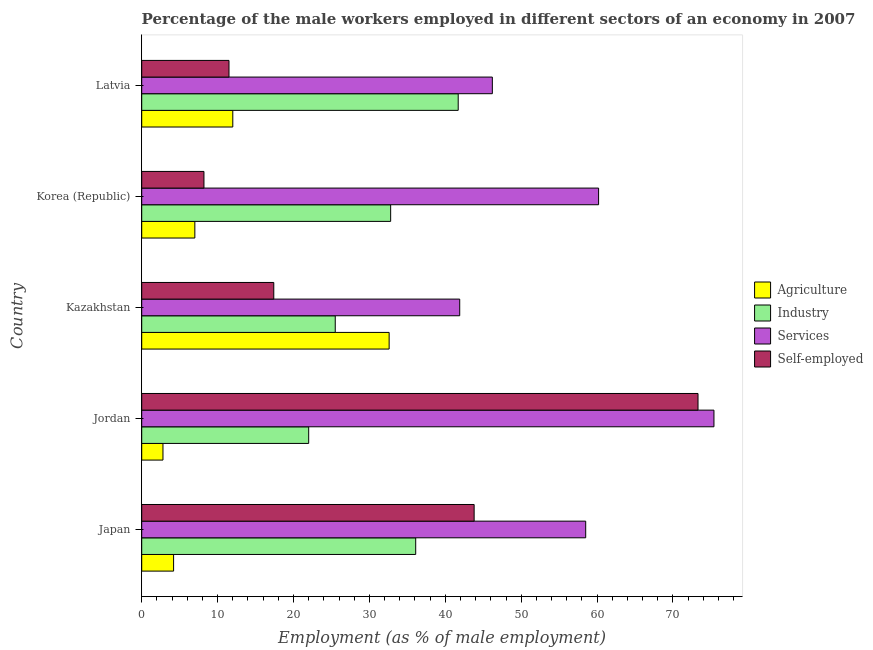How many groups of bars are there?
Offer a very short reply. 5. Are the number of bars on each tick of the Y-axis equal?
Your answer should be very brief. Yes. How many bars are there on the 3rd tick from the top?
Your answer should be compact. 4. What is the label of the 4th group of bars from the top?
Provide a succinct answer. Jordan. In how many cases, is the number of bars for a given country not equal to the number of legend labels?
Your answer should be compact. 0. Across all countries, what is the maximum percentage of male workers in agriculture?
Your answer should be very brief. 32.6. Across all countries, what is the minimum percentage of self employed male workers?
Offer a very short reply. 8.2. In which country was the percentage of male workers in agriculture maximum?
Provide a succinct answer. Kazakhstan. In which country was the percentage of male workers in industry minimum?
Keep it short and to the point. Jordan. What is the total percentage of self employed male workers in the graph?
Keep it short and to the point. 154.2. What is the difference between the percentage of self employed male workers in Japan and that in Korea (Republic)?
Your answer should be compact. 35.6. What is the difference between the percentage of male workers in services in Korea (Republic) and the percentage of male workers in industry in Kazakhstan?
Give a very brief answer. 34.7. What is the average percentage of self employed male workers per country?
Your response must be concise. 30.84. What is the difference between the percentage of male workers in services and percentage of male workers in industry in Latvia?
Your answer should be very brief. 4.5. In how many countries, is the percentage of self employed male workers greater than 10 %?
Ensure brevity in your answer.  4. What is the ratio of the percentage of male workers in industry in Japan to that in Latvia?
Keep it short and to the point. 0.87. Is the percentage of self employed male workers in Japan less than that in Latvia?
Provide a short and direct response. No. In how many countries, is the percentage of male workers in services greater than the average percentage of male workers in services taken over all countries?
Make the answer very short. 3. Is the sum of the percentage of male workers in industry in Japan and Latvia greater than the maximum percentage of male workers in services across all countries?
Keep it short and to the point. Yes. What does the 4th bar from the top in Kazakhstan represents?
Offer a terse response. Agriculture. What does the 4th bar from the bottom in Kazakhstan represents?
Offer a terse response. Self-employed. How many bars are there?
Offer a terse response. 20. Are all the bars in the graph horizontal?
Keep it short and to the point. Yes. How many countries are there in the graph?
Offer a very short reply. 5. What is the difference between two consecutive major ticks on the X-axis?
Your response must be concise. 10. Are the values on the major ticks of X-axis written in scientific E-notation?
Give a very brief answer. No. Does the graph contain grids?
Ensure brevity in your answer.  No. How many legend labels are there?
Give a very brief answer. 4. What is the title of the graph?
Offer a very short reply. Percentage of the male workers employed in different sectors of an economy in 2007. What is the label or title of the X-axis?
Your response must be concise. Employment (as % of male employment). What is the label or title of the Y-axis?
Keep it short and to the point. Country. What is the Employment (as % of male employment) in Agriculture in Japan?
Give a very brief answer. 4.2. What is the Employment (as % of male employment) of Industry in Japan?
Offer a terse response. 36.1. What is the Employment (as % of male employment) of Services in Japan?
Your response must be concise. 58.5. What is the Employment (as % of male employment) of Self-employed in Japan?
Ensure brevity in your answer.  43.8. What is the Employment (as % of male employment) in Agriculture in Jordan?
Your answer should be very brief. 2.8. What is the Employment (as % of male employment) in Services in Jordan?
Offer a terse response. 75.4. What is the Employment (as % of male employment) in Self-employed in Jordan?
Your answer should be very brief. 73.3. What is the Employment (as % of male employment) of Agriculture in Kazakhstan?
Give a very brief answer. 32.6. What is the Employment (as % of male employment) in Industry in Kazakhstan?
Your answer should be very brief. 25.5. What is the Employment (as % of male employment) in Services in Kazakhstan?
Offer a very short reply. 41.9. What is the Employment (as % of male employment) of Self-employed in Kazakhstan?
Your response must be concise. 17.4. What is the Employment (as % of male employment) in Agriculture in Korea (Republic)?
Your response must be concise. 7. What is the Employment (as % of male employment) of Industry in Korea (Republic)?
Make the answer very short. 32.8. What is the Employment (as % of male employment) in Services in Korea (Republic)?
Provide a succinct answer. 60.2. What is the Employment (as % of male employment) in Self-employed in Korea (Republic)?
Provide a short and direct response. 8.2. What is the Employment (as % of male employment) of Industry in Latvia?
Make the answer very short. 41.7. What is the Employment (as % of male employment) in Services in Latvia?
Provide a short and direct response. 46.2. Across all countries, what is the maximum Employment (as % of male employment) of Agriculture?
Keep it short and to the point. 32.6. Across all countries, what is the maximum Employment (as % of male employment) of Industry?
Ensure brevity in your answer.  41.7. Across all countries, what is the maximum Employment (as % of male employment) in Services?
Keep it short and to the point. 75.4. Across all countries, what is the maximum Employment (as % of male employment) in Self-employed?
Your answer should be very brief. 73.3. Across all countries, what is the minimum Employment (as % of male employment) in Agriculture?
Your response must be concise. 2.8. Across all countries, what is the minimum Employment (as % of male employment) in Services?
Offer a terse response. 41.9. Across all countries, what is the minimum Employment (as % of male employment) in Self-employed?
Your answer should be compact. 8.2. What is the total Employment (as % of male employment) of Agriculture in the graph?
Offer a very short reply. 58.6. What is the total Employment (as % of male employment) in Industry in the graph?
Make the answer very short. 158.1. What is the total Employment (as % of male employment) in Services in the graph?
Offer a terse response. 282.2. What is the total Employment (as % of male employment) of Self-employed in the graph?
Ensure brevity in your answer.  154.2. What is the difference between the Employment (as % of male employment) in Industry in Japan and that in Jordan?
Make the answer very short. 14.1. What is the difference between the Employment (as % of male employment) in Services in Japan and that in Jordan?
Provide a short and direct response. -16.9. What is the difference between the Employment (as % of male employment) in Self-employed in Japan and that in Jordan?
Give a very brief answer. -29.5. What is the difference between the Employment (as % of male employment) of Agriculture in Japan and that in Kazakhstan?
Ensure brevity in your answer.  -28.4. What is the difference between the Employment (as % of male employment) in Services in Japan and that in Kazakhstan?
Provide a short and direct response. 16.6. What is the difference between the Employment (as % of male employment) of Self-employed in Japan and that in Kazakhstan?
Ensure brevity in your answer.  26.4. What is the difference between the Employment (as % of male employment) in Industry in Japan and that in Korea (Republic)?
Give a very brief answer. 3.3. What is the difference between the Employment (as % of male employment) in Self-employed in Japan and that in Korea (Republic)?
Keep it short and to the point. 35.6. What is the difference between the Employment (as % of male employment) in Industry in Japan and that in Latvia?
Make the answer very short. -5.6. What is the difference between the Employment (as % of male employment) in Services in Japan and that in Latvia?
Give a very brief answer. 12.3. What is the difference between the Employment (as % of male employment) of Self-employed in Japan and that in Latvia?
Offer a very short reply. 32.3. What is the difference between the Employment (as % of male employment) of Agriculture in Jordan and that in Kazakhstan?
Provide a short and direct response. -29.8. What is the difference between the Employment (as % of male employment) in Industry in Jordan and that in Kazakhstan?
Ensure brevity in your answer.  -3.5. What is the difference between the Employment (as % of male employment) of Services in Jordan and that in Kazakhstan?
Ensure brevity in your answer.  33.5. What is the difference between the Employment (as % of male employment) in Self-employed in Jordan and that in Kazakhstan?
Keep it short and to the point. 55.9. What is the difference between the Employment (as % of male employment) in Self-employed in Jordan and that in Korea (Republic)?
Give a very brief answer. 65.1. What is the difference between the Employment (as % of male employment) of Industry in Jordan and that in Latvia?
Offer a very short reply. -19.7. What is the difference between the Employment (as % of male employment) of Services in Jordan and that in Latvia?
Make the answer very short. 29.2. What is the difference between the Employment (as % of male employment) in Self-employed in Jordan and that in Latvia?
Provide a succinct answer. 61.8. What is the difference between the Employment (as % of male employment) in Agriculture in Kazakhstan and that in Korea (Republic)?
Ensure brevity in your answer.  25.6. What is the difference between the Employment (as % of male employment) of Industry in Kazakhstan and that in Korea (Republic)?
Provide a short and direct response. -7.3. What is the difference between the Employment (as % of male employment) of Services in Kazakhstan and that in Korea (Republic)?
Make the answer very short. -18.3. What is the difference between the Employment (as % of male employment) in Agriculture in Kazakhstan and that in Latvia?
Keep it short and to the point. 20.6. What is the difference between the Employment (as % of male employment) of Industry in Kazakhstan and that in Latvia?
Provide a succinct answer. -16.2. What is the difference between the Employment (as % of male employment) of Services in Kazakhstan and that in Latvia?
Offer a terse response. -4.3. What is the difference between the Employment (as % of male employment) of Services in Korea (Republic) and that in Latvia?
Keep it short and to the point. 14. What is the difference between the Employment (as % of male employment) of Agriculture in Japan and the Employment (as % of male employment) of Industry in Jordan?
Provide a short and direct response. -17.8. What is the difference between the Employment (as % of male employment) in Agriculture in Japan and the Employment (as % of male employment) in Services in Jordan?
Offer a terse response. -71.2. What is the difference between the Employment (as % of male employment) of Agriculture in Japan and the Employment (as % of male employment) of Self-employed in Jordan?
Your answer should be compact. -69.1. What is the difference between the Employment (as % of male employment) in Industry in Japan and the Employment (as % of male employment) in Services in Jordan?
Make the answer very short. -39.3. What is the difference between the Employment (as % of male employment) of Industry in Japan and the Employment (as % of male employment) of Self-employed in Jordan?
Keep it short and to the point. -37.2. What is the difference between the Employment (as % of male employment) of Services in Japan and the Employment (as % of male employment) of Self-employed in Jordan?
Make the answer very short. -14.8. What is the difference between the Employment (as % of male employment) of Agriculture in Japan and the Employment (as % of male employment) of Industry in Kazakhstan?
Your response must be concise. -21.3. What is the difference between the Employment (as % of male employment) in Agriculture in Japan and the Employment (as % of male employment) in Services in Kazakhstan?
Provide a short and direct response. -37.7. What is the difference between the Employment (as % of male employment) of Agriculture in Japan and the Employment (as % of male employment) of Self-employed in Kazakhstan?
Ensure brevity in your answer.  -13.2. What is the difference between the Employment (as % of male employment) of Services in Japan and the Employment (as % of male employment) of Self-employed in Kazakhstan?
Offer a terse response. 41.1. What is the difference between the Employment (as % of male employment) of Agriculture in Japan and the Employment (as % of male employment) of Industry in Korea (Republic)?
Provide a succinct answer. -28.6. What is the difference between the Employment (as % of male employment) in Agriculture in Japan and the Employment (as % of male employment) in Services in Korea (Republic)?
Give a very brief answer. -56. What is the difference between the Employment (as % of male employment) in Agriculture in Japan and the Employment (as % of male employment) in Self-employed in Korea (Republic)?
Offer a terse response. -4. What is the difference between the Employment (as % of male employment) of Industry in Japan and the Employment (as % of male employment) of Services in Korea (Republic)?
Offer a terse response. -24.1. What is the difference between the Employment (as % of male employment) of Industry in Japan and the Employment (as % of male employment) of Self-employed in Korea (Republic)?
Offer a very short reply. 27.9. What is the difference between the Employment (as % of male employment) in Services in Japan and the Employment (as % of male employment) in Self-employed in Korea (Republic)?
Offer a very short reply. 50.3. What is the difference between the Employment (as % of male employment) in Agriculture in Japan and the Employment (as % of male employment) in Industry in Latvia?
Your response must be concise. -37.5. What is the difference between the Employment (as % of male employment) of Agriculture in Japan and the Employment (as % of male employment) of Services in Latvia?
Your response must be concise. -42. What is the difference between the Employment (as % of male employment) in Industry in Japan and the Employment (as % of male employment) in Services in Latvia?
Your answer should be very brief. -10.1. What is the difference between the Employment (as % of male employment) in Industry in Japan and the Employment (as % of male employment) in Self-employed in Latvia?
Your answer should be compact. 24.6. What is the difference between the Employment (as % of male employment) in Services in Japan and the Employment (as % of male employment) in Self-employed in Latvia?
Ensure brevity in your answer.  47. What is the difference between the Employment (as % of male employment) in Agriculture in Jordan and the Employment (as % of male employment) in Industry in Kazakhstan?
Offer a very short reply. -22.7. What is the difference between the Employment (as % of male employment) in Agriculture in Jordan and the Employment (as % of male employment) in Services in Kazakhstan?
Provide a short and direct response. -39.1. What is the difference between the Employment (as % of male employment) in Agriculture in Jordan and the Employment (as % of male employment) in Self-employed in Kazakhstan?
Provide a succinct answer. -14.6. What is the difference between the Employment (as % of male employment) in Industry in Jordan and the Employment (as % of male employment) in Services in Kazakhstan?
Provide a short and direct response. -19.9. What is the difference between the Employment (as % of male employment) of Industry in Jordan and the Employment (as % of male employment) of Self-employed in Kazakhstan?
Ensure brevity in your answer.  4.6. What is the difference between the Employment (as % of male employment) in Agriculture in Jordan and the Employment (as % of male employment) in Services in Korea (Republic)?
Make the answer very short. -57.4. What is the difference between the Employment (as % of male employment) in Agriculture in Jordan and the Employment (as % of male employment) in Self-employed in Korea (Republic)?
Your answer should be compact. -5.4. What is the difference between the Employment (as % of male employment) in Industry in Jordan and the Employment (as % of male employment) in Services in Korea (Republic)?
Give a very brief answer. -38.2. What is the difference between the Employment (as % of male employment) of Services in Jordan and the Employment (as % of male employment) of Self-employed in Korea (Republic)?
Your response must be concise. 67.2. What is the difference between the Employment (as % of male employment) in Agriculture in Jordan and the Employment (as % of male employment) in Industry in Latvia?
Offer a terse response. -38.9. What is the difference between the Employment (as % of male employment) of Agriculture in Jordan and the Employment (as % of male employment) of Services in Latvia?
Ensure brevity in your answer.  -43.4. What is the difference between the Employment (as % of male employment) of Industry in Jordan and the Employment (as % of male employment) of Services in Latvia?
Offer a terse response. -24.2. What is the difference between the Employment (as % of male employment) in Industry in Jordan and the Employment (as % of male employment) in Self-employed in Latvia?
Your answer should be compact. 10.5. What is the difference between the Employment (as % of male employment) of Services in Jordan and the Employment (as % of male employment) of Self-employed in Latvia?
Keep it short and to the point. 63.9. What is the difference between the Employment (as % of male employment) in Agriculture in Kazakhstan and the Employment (as % of male employment) in Services in Korea (Republic)?
Offer a very short reply. -27.6. What is the difference between the Employment (as % of male employment) of Agriculture in Kazakhstan and the Employment (as % of male employment) of Self-employed in Korea (Republic)?
Make the answer very short. 24.4. What is the difference between the Employment (as % of male employment) in Industry in Kazakhstan and the Employment (as % of male employment) in Services in Korea (Republic)?
Ensure brevity in your answer.  -34.7. What is the difference between the Employment (as % of male employment) in Industry in Kazakhstan and the Employment (as % of male employment) in Self-employed in Korea (Republic)?
Make the answer very short. 17.3. What is the difference between the Employment (as % of male employment) in Services in Kazakhstan and the Employment (as % of male employment) in Self-employed in Korea (Republic)?
Provide a short and direct response. 33.7. What is the difference between the Employment (as % of male employment) in Agriculture in Kazakhstan and the Employment (as % of male employment) in Industry in Latvia?
Your answer should be very brief. -9.1. What is the difference between the Employment (as % of male employment) of Agriculture in Kazakhstan and the Employment (as % of male employment) of Services in Latvia?
Your answer should be very brief. -13.6. What is the difference between the Employment (as % of male employment) of Agriculture in Kazakhstan and the Employment (as % of male employment) of Self-employed in Latvia?
Make the answer very short. 21.1. What is the difference between the Employment (as % of male employment) in Industry in Kazakhstan and the Employment (as % of male employment) in Services in Latvia?
Give a very brief answer. -20.7. What is the difference between the Employment (as % of male employment) in Services in Kazakhstan and the Employment (as % of male employment) in Self-employed in Latvia?
Your answer should be very brief. 30.4. What is the difference between the Employment (as % of male employment) in Agriculture in Korea (Republic) and the Employment (as % of male employment) in Industry in Latvia?
Give a very brief answer. -34.7. What is the difference between the Employment (as % of male employment) of Agriculture in Korea (Republic) and the Employment (as % of male employment) of Services in Latvia?
Ensure brevity in your answer.  -39.2. What is the difference between the Employment (as % of male employment) of Agriculture in Korea (Republic) and the Employment (as % of male employment) of Self-employed in Latvia?
Give a very brief answer. -4.5. What is the difference between the Employment (as % of male employment) in Industry in Korea (Republic) and the Employment (as % of male employment) in Services in Latvia?
Your answer should be very brief. -13.4. What is the difference between the Employment (as % of male employment) in Industry in Korea (Republic) and the Employment (as % of male employment) in Self-employed in Latvia?
Provide a succinct answer. 21.3. What is the difference between the Employment (as % of male employment) of Services in Korea (Republic) and the Employment (as % of male employment) of Self-employed in Latvia?
Your answer should be very brief. 48.7. What is the average Employment (as % of male employment) in Agriculture per country?
Keep it short and to the point. 11.72. What is the average Employment (as % of male employment) in Industry per country?
Your response must be concise. 31.62. What is the average Employment (as % of male employment) of Services per country?
Offer a very short reply. 56.44. What is the average Employment (as % of male employment) in Self-employed per country?
Your response must be concise. 30.84. What is the difference between the Employment (as % of male employment) of Agriculture and Employment (as % of male employment) of Industry in Japan?
Give a very brief answer. -31.9. What is the difference between the Employment (as % of male employment) of Agriculture and Employment (as % of male employment) of Services in Japan?
Give a very brief answer. -54.3. What is the difference between the Employment (as % of male employment) in Agriculture and Employment (as % of male employment) in Self-employed in Japan?
Your answer should be compact. -39.6. What is the difference between the Employment (as % of male employment) of Industry and Employment (as % of male employment) of Services in Japan?
Your response must be concise. -22.4. What is the difference between the Employment (as % of male employment) of Industry and Employment (as % of male employment) of Self-employed in Japan?
Ensure brevity in your answer.  -7.7. What is the difference between the Employment (as % of male employment) of Services and Employment (as % of male employment) of Self-employed in Japan?
Your answer should be very brief. 14.7. What is the difference between the Employment (as % of male employment) of Agriculture and Employment (as % of male employment) of Industry in Jordan?
Provide a succinct answer. -19.2. What is the difference between the Employment (as % of male employment) of Agriculture and Employment (as % of male employment) of Services in Jordan?
Your answer should be very brief. -72.6. What is the difference between the Employment (as % of male employment) of Agriculture and Employment (as % of male employment) of Self-employed in Jordan?
Offer a very short reply. -70.5. What is the difference between the Employment (as % of male employment) in Industry and Employment (as % of male employment) in Services in Jordan?
Your answer should be very brief. -53.4. What is the difference between the Employment (as % of male employment) in Industry and Employment (as % of male employment) in Self-employed in Jordan?
Your response must be concise. -51.3. What is the difference between the Employment (as % of male employment) in Services and Employment (as % of male employment) in Self-employed in Jordan?
Your answer should be compact. 2.1. What is the difference between the Employment (as % of male employment) in Agriculture and Employment (as % of male employment) in Services in Kazakhstan?
Make the answer very short. -9.3. What is the difference between the Employment (as % of male employment) in Agriculture and Employment (as % of male employment) in Self-employed in Kazakhstan?
Offer a very short reply. 15.2. What is the difference between the Employment (as % of male employment) of Industry and Employment (as % of male employment) of Services in Kazakhstan?
Provide a succinct answer. -16.4. What is the difference between the Employment (as % of male employment) in Agriculture and Employment (as % of male employment) in Industry in Korea (Republic)?
Give a very brief answer. -25.8. What is the difference between the Employment (as % of male employment) in Agriculture and Employment (as % of male employment) in Services in Korea (Republic)?
Ensure brevity in your answer.  -53.2. What is the difference between the Employment (as % of male employment) in Industry and Employment (as % of male employment) in Services in Korea (Republic)?
Your response must be concise. -27.4. What is the difference between the Employment (as % of male employment) of Industry and Employment (as % of male employment) of Self-employed in Korea (Republic)?
Offer a very short reply. 24.6. What is the difference between the Employment (as % of male employment) in Agriculture and Employment (as % of male employment) in Industry in Latvia?
Offer a terse response. -29.7. What is the difference between the Employment (as % of male employment) in Agriculture and Employment (as % of male employment) in Services in Latvia?
Offer a very short reply. -34.2. What is the difference between the Employment (as % of male employment) in Agriculture and Employment (as % of male employment) in Self-employed in Latvia?
Your answer should be very brief. 0.5. What is the difference between the Employment (as % of male employment) in Industry and Employment (as % of male employment) in Services in Latvia?
Offer a terse response. -4.5. What is the difference between the Employment (as % of male employment) of Industry and Employment (as % of male employment) of Self-employed in Latvia?
Give a very brief answer. 30.2. What is the difference between the Employment (as % of male employment) of Services and Employment (as % of male employment) of Self-employed in Latvia?
Your response must be concise. 34.7. What is the ratio of the Employment (as % of male employment) in Industry in Japan to that in Jordan?
Keep it short and to the point. 1.64. What is the ratio of the Employment (as % of male employment) of Services in Japan to that in Jordan?
Keep it short and to the point. 0.78. What is the ratio of the Employment (as % of male employment) in Self-employed in Japan to that in Jordan?
Keep it short and to the point. 0.6. What is the ratio of the Employment (as % of male employment) in Agriculture in Japan to that in Kazakhstan?
Your answer should be very brief. 0.13. What is the ratio of the Employment (as % of male employment) in Industry in Japan to that in Kazakhstan?
Your response must be concise. 1.42. What is the ratio of the Employment (as % of male employment) of Services in Japan to that in Kazakhstan?
Offer a very short reply. 1.4. What is the ratio of the Employment (as % of male employment) of Self-employed in Japan to that in Kazakhstan?
Offer a very short reply. 2.52. What is the ratio of the Employment (as % of male employment) in Agriculture in Japan to that in Korea (Republic)?
Provide a succinct answer. 0.6. What is the ratio of the Employment (as % of male employment) of Industry in Japan to that in Korea (Republic)?
Make the answer very short. 1.1. What is the ratio of the Employment (as % of male employment) in Services in Japan to that in Korea (Republic)?
Offer a very short reply. 0.97. What is the ratio of the Employment (as % of male employment) in Self-employed in Japan to that in Korea (Republic)?
Provide a succinct answer. 5.34. What is the ratio of the Employment (as % of male employment) in Industry in Japan to that in Latvia?
Make the answer very short. 0.87. What is the ratio of the Employment (as % of male employment) in Services in Japan to that in Latvia?
Provide a short and direct response. 1.27. What is the ratio of the Employment (as % of male employment) of Self-employed in Japan to that in Latvia?
Your answer should be compact. 3.81. What is the ratio of the Employment (as % of male employment) of Agriculture in Jordan to that in Kazakhstan?
Offer a terse response. 0.09. What is the ratio of the Employment (as % of male employment) in Industry in Jordan to that in Kazakhstan?
Keep it short and to the point. 0.86. What is the ratio of the Employment (as % of male employment) of Services in Jordan to that in Kazakhstan?
Keep it short and to the point. 1.8. What is the ratio of the Employment (as % of male employment) of Self-employed in Jordan to that in Kazakhstan?
Your answer should be very brief. 4.21. What is the ratio of the Employment (as % of male employment) in Agriculture in Jordan to that in Korea (Republic)?
Ensure brevity in your answer.  0.4. What is the ratio of the Employment (as % of male employment) of Industry in Jordan to that in Korea (Republic)?
Your answer should be compact. 0.67. What is the ratio of the Employment (as % of male employment) in Services in Jordan to that in Korea (Republic)?
Ensure brevity in your answer.  1.25. What is the ratio of the Employment (as % of male employment) of Self-employed in Jordan to that in Korea (Republic)?
Your answer should be compact. 8.94. What is the ratio of the Employment (as % of male employment) of Agriculture in Jordan to that in Latvia?
Provide a short and direct response. 0.23. What is the ratio of the Employment (as % of male employment) of Industry in Jordan to that in Latvia?
Make the answer very short. 0.53. What is the ratio of the Employment (as % of male employment) in Services in Jordan to that in Latvia?
Provide a succinct answer. 1.63. What is the ratio of the Employment (as % of male employment) of Self-employed in Jordan to that in Latvia?
Offer a terse response. 6.37. What is the ratio of the Employment (as % of male employment) of Agriculture in Kazakhstan to that in Korea (Republic)?
Provide a short and direct response. 4.66. What is the ratio of the Employment (as % of male employment) in Industry in Kazakhstan to that in Korea (Republic)?
Your answer should be very brief. 0.78. What is the ratio of the Employment (as % of male employment) in Services in Kazakhstan to that in Korea (Republic)?
Provide a succinct answer. 0.7. What is the ratio of the Employment (as % of male employment) of Self-employed in Kazakhstan to that in Korea (Republic)?
Your answer should be very brief. 2.12. What is the ratio of the Employment (as % of male employment) of Agriculture in Kazakhstan to that in Latvia?
Your answer should be very brief. 2.72. What is the ratio of the Employment (as % of male employment) in Industry in Kazakhstan to that in Latvia?
Make the answer very short. 0.61. What is the ratio of the Employment (as % of male employment) of Services in Kazakhstan to that in Latvia?
Provide a short and direct response. 0.91. What is the ratio of the Employment (as % of male employment) in Self-employed in Kazakhstan to that in Latvia?
Give a very brief answer. 1.51. What is the ratio of the Employment (as % of male employment) in Agriculture in Korea (Republic) to that in Latvia?
Your answer should be very brief. 0.58. What is the ratio of the Employment (as % of male employment) in Industry in Korea (Republic) to that in Latvia?
Provide a short and direct response. 0.79. What is the ratio of the Employment (as % of male employment) in Services in Korea (Republic) to that in Latvia?
Give a very brief answer. 1.3. What is the ratio of the Employment (as % of male employment) in Self-employed in Korea (Republic) to that in Latvia?
Provide a succinct answer. 0.71. What is the difference between the highest and the second highest Employment (as % of male employment) in Agriculture?
Offer a very short reply. 20.6. What is the difference between the highest and the second highest Employment (as % of male employment) of Services?
Offer a very short reply. 15.2. What is the difference between the highest and the second highest Employment (as % of male employment) in Self-employed?
Make the answer very short. 29.5. What is the difference between the highest and the lowest Employment (as % of male employment) of Agriculture?
Your answer should be very brief. 29.8. What is the difference between the highest and the lowest Employment (as % of male employment) of Services?
Keep it short and to the point. 33.5. What is the difference between the highest and the lowest Employment (as % of male employment) of Self-employed?
Keep it short and to the point. 65.1. 